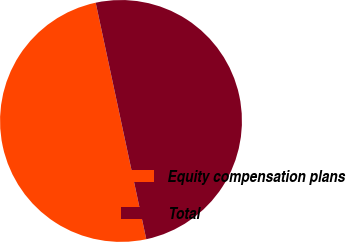<chart> <loc_0><loc_0><loc_500><loc_500><pie_chart><fcel>Equity compensation plans<fcel>Total<nl><fcel>50.0%<fcel>50.0%<nl></chart> 